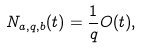<formula> <loc_0><loc_0><loc_500><loc_500>N _ { a , q , b } ( t ) = \frac { 1 } { q } O ( t ) ,</formula> 